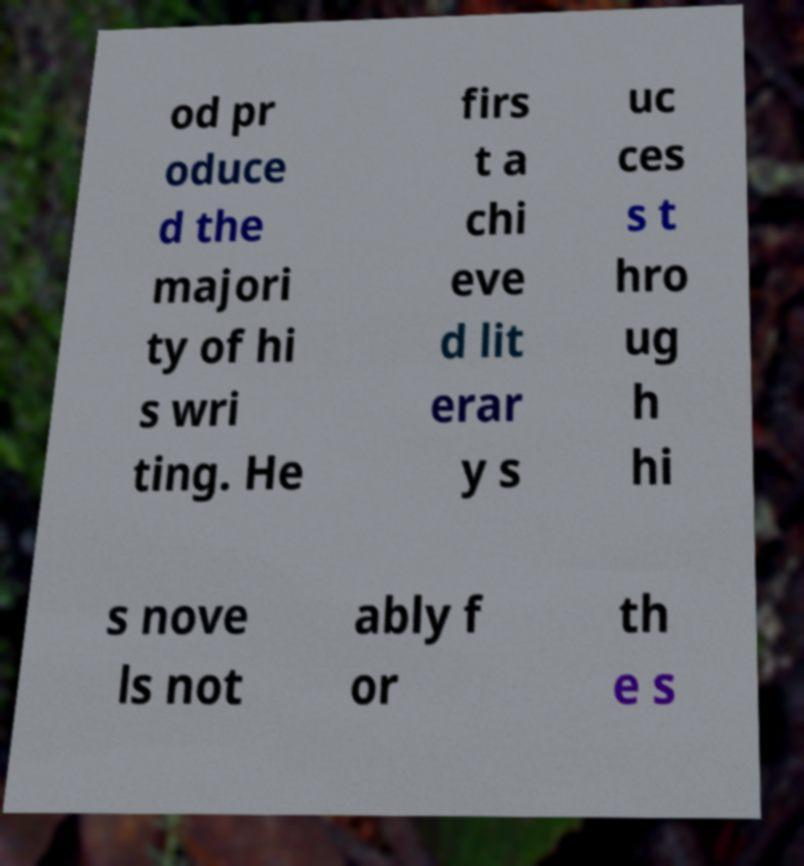Can you accurately transcribe the text from the provided image for me? od pr oduce d the majori ty of hi s wri ting. He firs t a chi eve d lit erar y s uc ces s t hro ug h hi s nove ls not ably f or th e s 